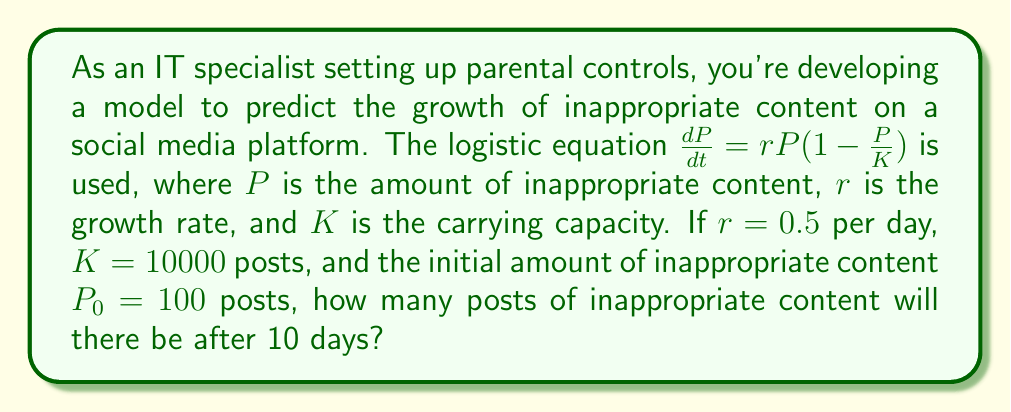Provide a solution to this math problem. To solve this problem, we'll use the logistic growth equation in its integrated form:

$$P(t) = \frac{K}{1 + (\frac{K}{P_0} - 1)e^{-rt}}$$

Where:
$P(t)$ is the population (inappropriate content) at time $t$
$K$ is the carrying capacity (10000 posts)
$P_0$ is the initial population (100 posts)
$r$ is the growth rate (0.5 per day)
$t$ is the time (10 days)

Let's substitute these values into the equation:

$$P(10) = \frac{10000}{1 + (\frac{10000}{100} - 1)e^{-0.5(10)}}$$

$$= \frac{10000}{1 + (100 - 1)e^{-5}}$$

$$= \frac{10000}{1 + 99e^{-5}}$$

Now, let's calculate $e^{-5}$:
$e^{-5} \approx 0.00674$

Substituting this back:

$$P(10) = \frac{10000}{1 + 99(0.00674)}$$

$$= \frac{10000}{1 + 0.66726}$$

$$= \frac{10000}{1.66726}$$

$$\approx 5997.66$$

Rounding to the nearest whole number (as we can't have fractional posts):

$$P(10) \approx 5998 \text{ posts}$$
Answer: 5998 posts 